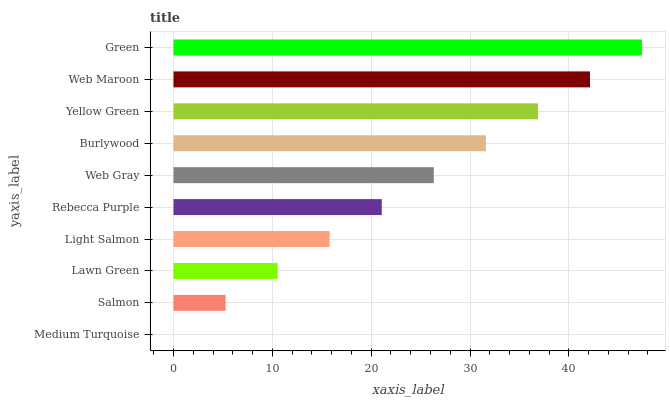Is Medium Turquoise the minimum?
Answer yes or no. Yes. Is Green the maximum?
Answer yes or no. Yes. Is Salmon the minimum?
Answer yes or no. No. Is Salmon the maximum?
Answer yes or no. No. Is Salmon greater than Medium Turquoise?
Answer yes or no. Yes. Is Medium Turquoise less than Salmon?
Answer yes or no. Yes. Is Medium Turquoise greater than Salmon?
Answer yes or no. No. Is Salmon less than Medium Turquoise?
Answer yes or no. No. Is Web Gray the high median?
Answer yes or no. Yes. Is Rebecca Purple the low median?
Answer yes or no. Yes. Is Yellow Green the high median?
Answer yes or no. No. Is Salmon the low median?
Answer yes or no. No. 